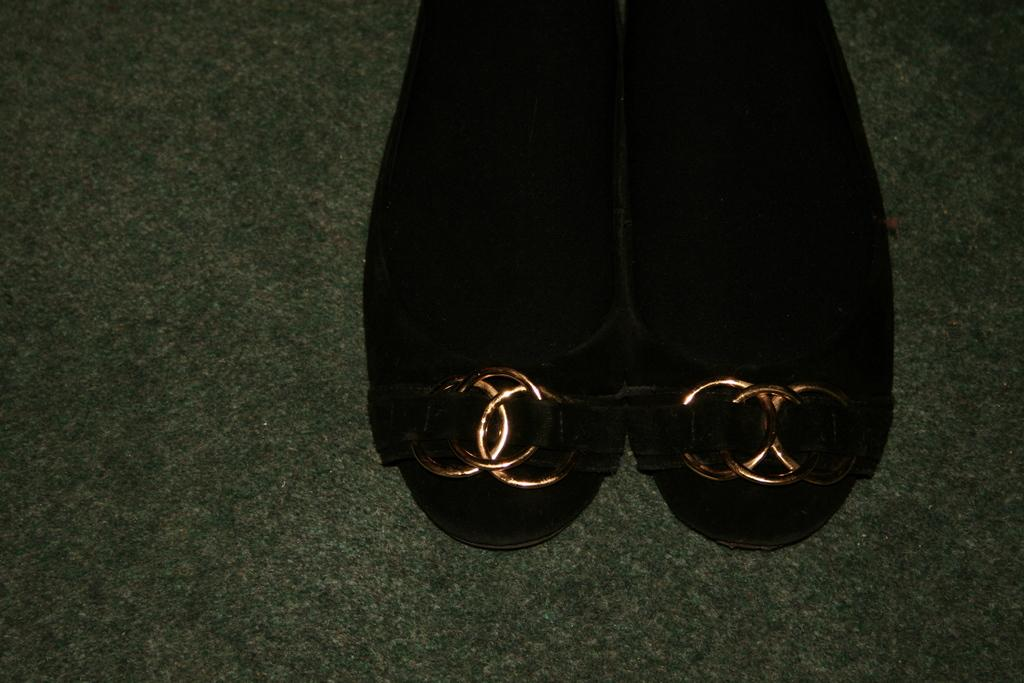What type of object is present in the image? There is footwear in the image. What color is the footwear? The footwear is black in color. Are there any patterns or designs on the footwear? Yes, the footwear has designs on it. Where is the cactus located in the image? There is no cactus present in the image. What type of string is used to tie the footwear together in the image? The image does not show any string or tying of the footwear. 